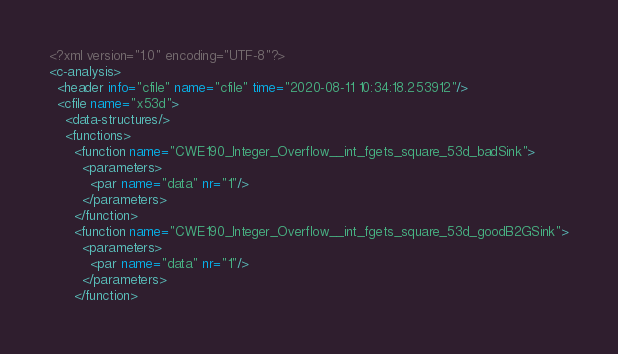Convert code to text. <code><loc_0><loc_0><loc_500><loc_500><_XML_><?xml version="1.0" encoding="UTF-8"?>
<c-analysis>
  <header info="cfile" name="cfile" time="2020-08-11 10:34:18.253912"/>
  <cfile name="x53d">
    <data-structures/>
    <functions>
      <function name="CWE190_Integer_Overflow__int_fgets_square_53d_badSink">
        <parameters>
          <par name="data" nr="1"/>
        </parameters>
      </function>
      <function name="CWE190_Integer_Overflow__int_fgets_square_53d_goodB2GSink">
        <parameters>
          <par name="data" nr="1"/>
        </parameters>
      </function></code> 